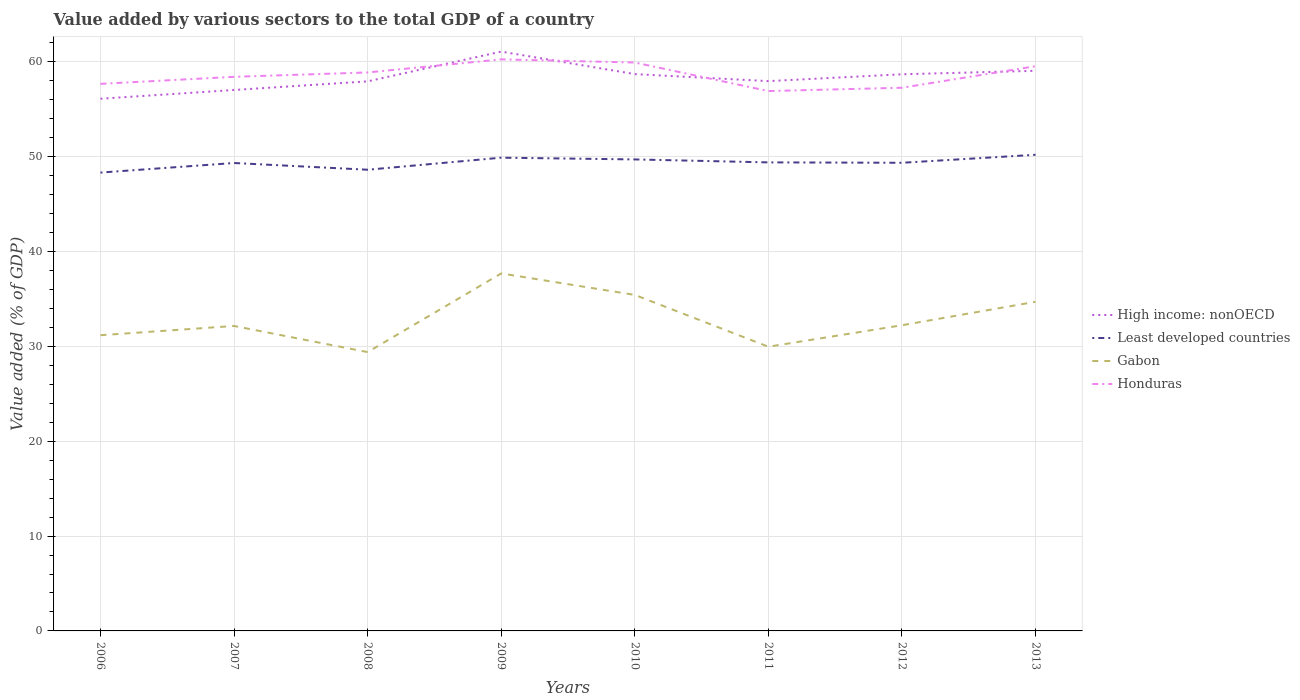Does the line corresponding to High income: nonOECD intersect with the line corresponding to Honduras?
Give a very brief answer. Yes. Across all years, what is the maximum value added by various sectors to the total GDP in High income: nonOECD?
Provide a short and direct response. 56.12. In which year was the value added by various sectors to the total GDP in Least developed countries maximum?
Ensure brevity in your answer.  2006. What is the total value added by various sectors to the total GDP in Honduras in the graph?
Your response must be concise. 0.76. What is the difference between the highest and the second highest value added by various sectors to the total GDP in Honduras?
Provide a short and direct response. 3.34. What is the difference between the highest and the lowest value added by various sectors to the total GDP in High income: nonOECD?
Your response must be concise. 4. Is the value added by various sectors to the total GDP in Least developed countries strictly greater than the value added by various sectors to the total GDP in High income: nonOECD over the years?
Offer a very short reply. Yes. How many years are there in the graph?
Ensure brevity in your answer.  8. What is the difference between two consecutive major ticks on the Y-axis?
Your answer should be very brief. 10. Does the graph contain any zero values?
Your answer should be very brief. No. Where does the legend appear in the graph?
Offer a terse response. Center right. How many legend labels are there?
Your response must be concise. 4. How are the legend labels stacked?
Give a very brief answer. Vertical. What is the title of the graph?
Provide a succinct answer. Value added by various sectors to the total GDP of a country. What is the label or title of the X-axis?
Your response must be concise. Years. What is the label or title of the Y-axis?
Provide a short and direct response. Value added (% of GDP). What is the Value added (% of GDP) of High income: nonOECD in 2006?
Provide a succinct answer. 56.12. What is the Value added (% of GDP) in Least developed countries in 2006?
Provide a short and direct response. 48.33. What is the Value added (% of GDP) in Gabon in 2006?
Offer a very short reply. 31.18. What is the Value added (% of GDP) in Honduras in 2006?
Ensure brevity in your answer.  57.69. What is the Value added (% of GDP) in High income: nonOECD in 2007?
Provide a short and direct response. 57.04. What is the Value added (% of GDP) in Least developed countries in 2007?
Give a very brief answer. 49.34. What is the Value added (% of GDP) in Gabon in 2007?
Offer a very short reply. 32.16. What is the Value added (% of GDP) in Honduras in 2007?
Ensure brevity in your answer.  58.43. What is the Value added (% of GDP) in High income: nonOECD in 2008?
Offer a very short reply. 57.95. What is the Value added (% of GDP) of Least developed countries in 2008?
Keep it short and to the point. 48.63. What is the Value added (% of GDP) of Gabon in 2008?
Your answer should be very brief. 29.4. What is the Value added (% of GDP) of Honduras in 2008?
Keep it short and to the point. 58.89. What is the Value added (% of GDP) of High income: nonOECD in 2009?
Offer a terse response. 61.09. What is the Value added (% of GDP) of Least developed countries in 2009?
Your response must be concise. 49.9. What is the Value added (% of GDP) in Gabon in 2009?
Give a very brief answer. 37.7. What is the Value added (% of GDP) of Honduras in 2009?
Your response must be concise. 60.27. What is the Value added (% of GDP) of High income: nonOECD in 2010?
Your answer should be very brief. 58.71. What is the Value added (% of GDP) of Least developed countries in 2010?
Offer a very short reply. 49.72. What is the Value added (% of GDP) in Gabon in 2010?
Your answer should be compact. 35.43. What is the Value added (% of GDP) of Honduras in 2010?
Keep it short and to the point. 59.93. What is the Value added (% of GDP) in High income: nonOECD in 2011?
Your answer should be very brief. 57.98. What is the Value added (% of GDP) of Least developed countries in 2011?
Your response must be concise. 49.41. What is the Value added (% of GDP) of Gabon in 2011?
Your answer should be very brief. 29.97. What is the Value added (% of GDP) in Honduras in 2011?
Provide a short and direct response. 56.93. What is the Value added (% of GDP) of High income: nonOECD in 2012?
Offer a very short reply. 58.7. What is the Value added (% of GDP) of Least developed countries in 2012?
Your answer should be very brief. 49.36. What is the Value added (% of GDP) in Gabon in 2012?
Your answer should be very brief. 32.23. What is the Value added (% of GDP) in Honduras in 2012?
Your answer should be very brief. 57.28. What is the Value added (% of GDP) in High income: nonOECD in 2013?
Provide a short and direct response. 59.06. What is the Value added (% of GDP) of Least developed countries in 2013?
Provide a short and direct response. 50.21. What is the Value added (% of GDP) in Gabon in 2013?
Ensure brevity in your answer.  34.71. What is the Value added (% of GDP) in Honduras in 2013?
Your response must be concise. 59.55. Across all years, what is the maximum Value added (% of GDP) of High income: nonOECD?
Your response must be concise. 61.09. Across all years, what is the maximum Value added (% of GDP) of Least developed countries?
Your answer should be very brief. 50.21. Across all years, what is the maximum Value added (% of GDP) in Gabon?
Offer a very short reply. 37.7. Across all years, what is the maximum Value added (% of GDP) in Honduras?
Offer a very short reply. 60.27. Across all years, what is the minimum Value added (% of GDP) in High income: nonOECD?
Offer a terse response. 56.12. Across all years, what is the minimum Value added (% of GDP) of Least developed countries?
Provide a short and direct response. 48.33. Across all years, what is the minimum Value added (% of GDP) in Gabon?
Provide a succinct answer. 29.4. Across all years, what is the minimum Value added (% of GDP) of Honduras?
Offer a very short reply. 56.93. What is the total Value added (% of GDP) in High income: nonOECD in the graph?
Your response must be concise. 466.65. What is the total Value added (% of GDP) in Least developed countries in the graph?
Offer a terse response. 394.9. What is the total Value added (% of GDP) in Gabon in the graph?
Provide a short and direct response. 262.78. What is the total Value added (% of GDP) of Honduras in the graph?
Ensure brevity in your answer.  468.96. What is the difference between the Value added (% of GDP) of High income: nonOECD in 2006 and that in 2007?
Make the answer very short. -0.92. What is the difference between the Value added (% of GDP) of Least developed countries in 2006 and that in 2007?
Your answer should be very brief. -1.01. What is the difference between the Value added (% of GDP) of Gabon in 2006 and that in 2007?
Provide a succinct answer. -0.98. What is the difference between the Value added (% of GDP) in Honduras in 2006 and that in 2007?
Your answer should be very brief. -0.74. What is the difference between the Value added (% of GDP) in High income: nonOECD in 2006 and that in 2008?
Offer a very short reply. -1.83. What is the difference between the Value added (% of GDP) in Least developed countries in 2006 and that in 2008?
Give a very brief answer. -0.3. What is the difference between the Value added (% of GDP) in Gabon in 2006 and that in 2008?
Your answer should be compact. 1.78. What is the difference between the Value added (% of GDP) in Honduras in 2006 and that in 2008?
Offer a very short reply. -1.2. What is the difference between the Value added (% of GDP) of High income: nonOECD in 2006 and that in 2009?
Your answer should be very brief. -4.97. What is the difference between the Value added (% of GDP) of Least developed countries in 2006 and that in 2009?
Your answer should be very brief. -1.57. What is the difference between the Value added (% of GDP) of Gabon in 2006 and that in 2009?
Your response must be concise. -6.51. What is the difference between the Value added (% of GDP) of Honduras in 2006 and that in 2009?
Offer a terse response. -2.58. What is the difference between the Value added (% of GDP) of High income: nonOECD in 2006 and that in 2010?
Your answer should be very brief. -2.6. What is the difference between the Value added (% of GDP) in Least developed countries in 2006 and that in 2010?
Offer a terse response. -1.39. What is the difference between the Value added (% of GDP) in Gabon in 2006 and that in 2010?
Keep it short and to the point. -4.25. What is the difference between the Value added (% of GDP) in Honduras in 2006 and that in 2010?
Provide a short and direct response. -2.25. What is the difference between the Value added (% of GDP) of High income: nonOECD in 2006 and that in 2011?
Make the answer very short. -1.86. What is the difference between the Value added (% of GDP) of Least developed countries in 2006 and that in 2011?
Ensure brevity in your answer.  -1.07. What is the difference between the Value added (% of GDP) in Gabon in 2006 and that in 2011?
Provide a short and direct response. 1.21. What is the difference between the Value added (% of GDP) of Honduras in 2006 and that in 2011?
Offer a terse response. 0.76. What is the difference between the Value added (% of GDP) of High income: nonOECD in 2006 and that in 2012?
Your answer should be very brief. -2.58. What is the difference between the Value added (% of GDP) of Least developed countries in 2006 and that in 2012?
Ensure brevity in your answer.  -1.03. What is the difference between the Value added (% of GDP) of Gabon in 2006 and that in 2012?
Provide a succinct answer. -1.05. What is the difference between the Value added (% of GDP) of Honduras in 2006 and that in 2012?
Make the answer very short. 0.41. What is the difference between the Value added (% of GDP) in High income: nonOECD in 2006 and that in 2013?
Give a very brief answer. -2.95. What is the difference between the Value added (% of GDP) of Least developed countries in 2006 and that in 2013?
Keep it short and to the point. -1.88. What is the difference between the Value added (% of GDP) of Gabon in 2006 and that in 2013?
Keep it short and to the point. -3.53. What is the difference between the Value added (% of GDP) in Honduras in 2006 and that in 2013?
Ensure brevity in your answer.  -1.86. What is the difference between the Value added (% of GDP) in High income: nonOECD in 2007 and that in 2008?
Make the answer very short. -0.91. What is the difference between the Value added (% of GDP) of Least developed countries in 2007 and that in 2008?
Provide a short and direct response. 0.71. What is the difference between the Value added (% of GDP) of Gabon in 2007 and that in 2008?
Your response must be concise. 2.76. What is the difference between the Value added (% of GDP) in Honduras in 2007 and that in 2008?
Provide a short and direct response. -0.46. What is the difference between the Value added (% of GDP) in High income: nonOECD in 2007 and that in 2009?
Provide a short and direct response. -4.05. What is the difference between the Value added (% of GDP) of Least developed countries in 2007 and that in 2009?
Give a very brief answer. -0.56. What is the difference between the Value added (% of GDP) in Gabon in 2007 and that in 2009?
Make the answer very short. -5.54. What is the difference between the Value added (% of GDP) in Honduras in 2007 and that in 2009?
Your response must be concise. -1.84. What is the difference between the Value added (% of GDP) of High income: nonOECD in 2007 and that in 2010?
Provide a short and direct response. -1.67. What is the difference between the Value added (% of GDP) in Least developed countries in 2007 and that in 2010?
Offer a very short reply. -0.38. What is the difference between the Value added (% of GDP) in Gabon in 2007 and that in 2010?
Ensure brevity in your answer.  -3.27. What is the difference between the Value added (% of GDP) in Honduras in 2007 and that in 2010?
Offer a terse response. -1.51. What is the difference between the Value added (% of GDP) of High income: nonOECD in 2007 and that in 2011?
Your answer should be very brief. -0.94. What is the difference between the Value added (% of GDP) of Least developed countries in 2007 and that in 2011?
Give a very brief answer. -0.07. What is the difference between the Value added (% of GDP) in Gabon in 2007 and that in 2011?
Your answer should be very brief. 2.19. What is the difference between the Value added (% of GDP) in Honduras in 2007 and that in 2011?
Keep it short and to the point. 1.5. What is the difference between the Value added (% of GDP) in High income: nonOECD in 2007 and that in 2012?
Ensure brevity in your answer.  -1.66. What is the difference between the Value added (% of GDP) of Least developed countries in 2007 and that in 2012?
Ensure brevity in your answer.  -0.02. What is the difference between the Value added (% of GDP) of Gabon in 2007 and that in 2012?
Provide a short and direct response. -0.08. What is the difference between the Value added (% of GDP) of Honduras in 2007 and that in 2012?
Provide a succinct answer. 1.15. What is the difference between the Value added (% of GDP) in High income: nonOECD in 2007 and that in 2013?
Provide a succinct answer. -2.02. What is the difference between the Value added (% of GDP) in Least developed countries in 2007 and that in 2013?
Provide a succinct answer. -0.87. What is the difference between the Value added (% of GDP) of Gabon in 2007 and that in 2013?
Give a very brief answer. -2.55. What is the difference between the Value added (% of GDP) of Honduras in 2007 and that in 2013?
Offer a terse response. -1.12. What is the difference between the Value added (% of GDP) of High income: nonOECD in 2008 and that in 2009?
Your answer should be very brief. -3.14. What is the difference between the Value added (% of GDP) of Least developed countries in 2008 and that in 2009?
Your answer should be compact. -1.27. What is the difference between the Value added (% of GDP) of Gabon in 2008 and that in 2009?
Ensure brevity in your answer.  -8.29. What is the difference between the Value added (% of GDP) of Honduras in 2008 and that in 2009?
Your answer should be very brief. -1.38. What is the difference between the Value added (% of GDP) in High income: nonOECD in 2008 and that in 2010?
Keep it short and to the point. -0.76. What is the difference between the Value added (% of GDP) in Least developed countries in 2008 and that in 2010?
Offer a very short reply. -1.09. What is the difference between the Value added (% of GDP) of Gabon in 2008 and that in 2010?
Keep it short and to the point. -6.03. What is the difference between the Value added (% of GDP) in Honduras in 2008 and that in 2010?
Your answer should be compact. -1.05. What is the difference between the Value added (% of GDP) in High income: nonOECD in 2008 and that in 2011?
Make the answer very short. -0.02. What is the difference between the Value added (% of GDP) in Least developed countries in 2008 and that in 2011?
Make the answer very short. -0.77. What is the difference between the Value added (% of GDP) of Gabon in 2008 and that in 2011?
Provide a succinct answer. -0.57. What is the difference between the Value added (% of GDP) of Honduras in 2008 and that in 2011?
Make the answer very short. 1.96. What is the difference between the Value added (% of GDP) of High income: nonOECD in 2008 and that in 2012?
Offer a very short reply. -0.75. What is the difference between the Value added (% of GDP) in Least developed countries in 2008 and that in 2012?
Your answer should be very brief. -0.73. What is the difference between the Value added (% of GDP) of Gabon in 2008 and that in 2012?
Give a very brief answer. -2.83. What is the difference between the Value added (% of GDP) in Honduras in 2008 and that in 2012?
Your response must be concise. 1.61. What is the difference between the Value added (% of GDP) of High income: nonOECD in 2008 and that in 2013?
Your answer should be very brief. -1.11. What is the difference between the Value added (% of GDP) in Least developed countries in 2008 and that in 2013?
Offer a terse response. -1.58. What is the difference between the Value added (% of GDP) in Gabon in 2008 and that in 2013?
Keep it short and to the point. -5.31. What is the difference between the Value added (% of GDP) of Honduras in 2008 and that in 2013?
Offer a terse response. -0.66. What is the difference between the Value added (% of GDP) in High income: nonOECD in 2009 and that in 2010?
Ensure brevity in your answer.  2.37. What is the difference between the Value added (% of GDP) in Least developed countries in 2009 and that in 2010?
Provide a succinct answer. 0.18. What is the difference between the Value added (% of GDP) in Gabon in 2009 and that in 2010?
Make the answer very short. 2.27. What is the difference between the Value added (% of GDP) in Honduras in 2009 and that in 2010?
Give a very brief answer. 0.34. What is the difference between the Value added (% of GDP) in High income: nonOECD in 2009 and that in 2011?
Keep it short and to the point. 3.11. What is the difference between the Value added (% of GDP) in Least developed countries in 2009 and that in 2011?
Ensure brevity in your answer.  0.5. What is the difference between the Value added (% of GDP) in Gabon in 2009 and that in 2011?
Ensure brevity in your answer.  7.73. What is the difference between the Value added (% of GDP) in Honduras in 2009 and that in 2011?
Your answer should be very brief. 3.34. What is the difference between the Value added (% of GDP) of High income: nonOECD in 2009 and that in 2012?
Ensure brevity in your answer.  2.39. What is the difference between the Value added (% of GDP) in Least developed countries in 2009 and that in 2012?
Provide a succinct answer. 0.54. What is the difference between the Value added (% of GDP) of Gabon in 2009 and that in 2012?
Offer a terse response. 5.46. What is the difference between the Value added (% of GDP) in Honduras in 2009 and that in 2012?
Ensure brevity in your answer.  2.99. What is the difference between the Value added (% of GDP) in High income: nonOECD in 2009 and that in 2013?
Ensure brevity in your answer.  2.02. What is the difference between the Value added (% of GDP) in Least developed countries in 2009 and that in 2013?
Make the answer very short. -0.3. What is the difference between the Value added (% of GDP) of Gabon in 2009 and that in 2013?
Keep it short and to the point. 2.99. What is the difference between the Value added (% of GDP) of Honduras in 2009 and that in 2013?
Offer a very short reply. 0.72. What is the difference between the Value added (% of GDP) in High income: nonOECD in 2010 and that in 2011?
Ensure brevity in your answer.  0.74. What is the difference between the Value added (% of GDP) in Least developed countries in 2010 and that in 2011?
Provide a short and direct response. 0.31. What is the difference between the Value added (% of GDP) in Gabon in 2010 and that in 2011?
Offer a terse response. 5.46. What is the difference between the Value added (% of GDP) of Honduras in 2010 and that in 2011?
Your answer should be compact. 3.01. What is the difference between the Value added (% of GDP) in High income: nonOECD in 2010 and that in 2012?
Offer a terse response. 0.02. What is the difference between the Value added (% of GDP) of Least developed countries in 2010 and that in 2012?
Make the answer very short. 0.35. What is the difference between the Value added (% of GDP) in Gabon in 2010 and that in 2012?
Your response must be concise. 3.2. What is the difference between the Value added (% of GDP) in Honduras in 2010 and that in 2012?
Make the answer very short. 2.66. What is the difference between the Value added (% of GDP) in High income: nonOECD in 2010 and that in 2013?
Provide a short and direct response. -0.35. What is the difference between the Value added (% of GDP) in Least developed countries in 2010 and that in 2013?
Offer a terse response. -0.49. What is the difference between the Value added (% of GDP) in Gabon in 2010 and that in 2013?
Your answer should be compact. 0.72. What is the difference between the Value added (% of GDP) in Honduras in 2010 and that in 2013?
Keep it short and to the point. 0.39. What is the difference between the Value added (% of GDP) in High income: nonOECD in 2011 and that in 2012?
Provide a short and direct response. -0.72. What is the difference between the Value added (% of GDP) of Least developed countries in 2011 and that in 2012?
Give a very brief answer. 0.04. What is the difference between the Value added (% of GDP) in Gabon in 2011 and that in 2012?
Your answer should be compact. -2.26. What is the difference between the Value added (% of GDP) in Honduras in 2011 and that in 2012?
Offer a very short reply. -0.35. What is the difference between the Value added (% of GDP) in High income: nonOECD in 2011 and that in 2013?
Ensure brevity in your answer.  -1.09. What is the difference between the Value added (% of GDP) of Least developed countries in 2011 and that in 2013?
Your answer should be compact. -0.8. What is the difference between the Value added (% of GDP) of Gabon in 2011 and that in 2013?
Offer a very short reply. -4.74. What is the difference between the Value added (% of GDP) in Honduras in 2011 and that in 2013?
Your response must be concise. -2.62. What is the difference between the Value added (% of GDP) in High income: nonOECD in 2012 and that in 2013?
Offer a terse response. -0.37. What is the difference between the Value added (% of GDP) of Least developed countries in 2012 and that in 2013?
Provide a short and direct response. -0.84. What is the difference between the Value added (% of GDP) of Gabon in 2012 and that in 2013?
Offer a terse response. -2.48. What is the difference between the Value added (% of GDP) in Honduras in 2012 and that in 2013?
Provide a succinct answer. -2.27. What is the difference between the Value added (% of GDP) in High income: nonOECD in 2006 and the Value added (% of GDP) in Least developed countries in 2007?
Your answer should be very brief. 6.78. What is the difference between the Value added (% of GDP) in High income: nonOECD in 2006 and the Value added (% of GDP) in Gabon in 2007?
Offer a terse response. 23.96. What is the difference between the Value added (% of GDP) in High income: nonOECD in 2006 and the Value added (% of GDP) in Honduras in 2007?
Provide a succinct answer. -2.31. What is the difference between the Value added (% of GDP) in Least developed countries in 2006 and the Value added (% of GDP) in Gabon in 2007?
Give a very brief answer. 16.18. What is the difference between the Value added (% of GDP) of Least developed countries in 2006 and the Value added (% of GDP) of Honduras in 2007?
Make the answer very short. -10.1. What is the difference between the Value added (% of GDP) in Gabon in 2006 and the Value added (% of GDP) in Honduras in 2007?
Provide a succinct answer. -27.25. What is the difference between the Value added (% of GDP) of High income: nonOECD in 2006 and the Value added (% of GDP) of Least developed countries in 2008?
Your answer should be compact. 7.49. What is the difference between the Value added (% of GDP) in High income: nonOECD in 2006 and the Value added (% of GDP) in Gabon in 2008?
Give a very brief answer. 26.72. What is the difference between the Value added (% of GDP) in High income: nonOECD in 2006 and the Value added (% of GDP) in Honduras in 2008?
Your answer should be very brief. -2.77. What is the difference between the Value added (% of GDP) of Least developed countries in 2006 and the Value added (% of GDP) of Gabon in 2008?
Offer a very short reply. 18.93. What is the difference between the Value added (% of GDP) in Least developed countries in 2006 and the Value added (% of GDP) in Honduras in 2008?
Ensure brevity in your answer.  -10.56. What is the difference between the Value added (% of GDP) of Gabon in 2006 and the Value added (% of GDP) of Honduras in 2008?
Give a very brief answer. -27.71. What is the difference between the Value added (% of GDP) of High income: nonOECD in 2006 and the Value added (% of GDP) of Least developed countries in 2009?
Make the answer very short. 6.21. What is the difference between the Value added (% of GDP) of High income: nonOECD in 2006 and the Value added (% of GDP) of Gabon in 2009?
Keep it short and to the point. 18.42. What is the difference between the Value added (% of GDP) in High income: nonOECD in 2006 and the Value added (% of GDP) in Honduras in 2009?
Ensure brevity in your answer.  -4.15. What is the difference between the Value added (% of GDP) of Least developed countries in 2006 and the Value added (% of GDP) of Gabon in 2009?
Offer a very short reply. 10.64. What is the difference between the Value added (% of GDP) in Least developed countries in 2006 and the Value added (% of GDP) in Honduras in 2009?
Keep it short and to the point. -11.94. What is the difference between the Value added (% of GDP) of Gabon in 2006 and the Value added (% of GDP) of Honduras in 2009?
Offer a very short reply. -29.09. What is the difference between the Value added (% of GDP) of High income: nonOECD in 2006 and the Value added (% of GDP) of Least developed countries in 2010?
Offer a terse response. 6.4. What is the difference between the Value added (% of GDP) in High income: nonOECD in 2006 and the Value added (% of GDP) in Gabon in 2010?
Make the answer very short. 20.69. What is the difference between the Value added (% of GDP) of High income: nonOECD in 2006 and the Value added (% of GDP) of Honduras in 2010?
Provide a succinct answer. -3.82. What is the difference between the Value added (% of GDP) of Least developed countries in 2006 and the Value added (% of GDP) of Gabon in 2010?
Make the answer very short. 12.9. What is the difference between the Value added (% of GDP) in Least developed countries in 2006 and the Value added (% of GDP) in Honduras in 2010?
Make the answer very short. -11.6. What is the difference between the Value added (% of GDP) of Gabon in 2006 and the Value added (% of GDP) of Honduras in 2010?
Make the answer very short. -28.75. What is the difference between the Value added (% of GDP) of High income: nonOECD in 2006 and the Value added (% of GDP) of Least developed countries in 2011?
Offer a terse response. 6.71. What is the difference between the Value added (% of GDP) of High income: nonOECD in 2006 and the Value added (% of GDP) of Gabon in 2011?
Provide a short and direct response. 26.15. What is the difference between the Value added (% of GDP) in High income: nonOECD in 2006 and the Value added (% of GDP) in Honduras in 2011?
Your response must be concise. -0.81. What is the difference between the Value added (% of GDP) of Least developed countries in 2006 and the Value added (% of GDP) of Gabon in 2011?
Your response must be concise. 18.36. What is the difference between the Value added (% of GDP) of Least developed countries in 2006 and the Value added (% of GDP) of Honduras in 2011?
Provide a succinct answer. -8.59. What is the difference between the Value added (% of GDP) of Gabon in 2006 and the Value added (% of GDP) of Honduras in 2011?
Make the answer very short. -25.74. What is the difference between the Value added (% of GDP) in High income: nonOECD in 2006 and the Value added (% of GDP) in Least developed countries in 2012?
Provide a succinct answer. 6.75. What is the difference between the Value added (% of GDP) in High income: nonOECD in 2006 and the Value added (% of GDP) in Gabon in 2012?
Give a very brief answer. 23.89. What is the difference between the Value added (% of GDP) of High income: nonOECD in 2006 and the Value added (% of GDP) of Honduras in 2012?
Make the answer very short. -1.16. What is the difference between the Value added (% of GDP) of Least developed countries in 2006 and the Value added (% of GDP) of Gabon in 2012?
Make the answer very short. 16.1. What is the difference between the Value added (% of GDP) of Least developed countries in 2006 and the Value added (% of GDP) of Honduras in 2012?
Your response must be concise. -8.94. What is the difference between the Value added (% of GDP) of Gabon in 2006 and the Value added (% of GDP) of Honduras in 2012?
Offer a terse response. -26.09. What is the difference between the Value added (% of GDP) in High income: nonOECD in 2006 and the Value added (% of GDP) in Least developed countries in 2013?
Give a very brief answer. 5.91. What is the difference between the Value added (% of GDP) in High income: nonOECD in 2006 and the Value added (% of GDP) in Gabon in 2013?
Make the answer very short. 21.41. What is the difference between the Value added (% of GDP) of High income: nonOECD in 2006 and the Value added (% of GDP) of Honduras in 2013?
Offer a terse response. -3.43. What is the difference between the Value added (% of GDP) of Least developed countries in 2006 and the Value added (% of GDP) of Gabon in 2013?
Ensure brevity in your answer.  13.62. What is the difference between the Value added (% of GDP) in Least developed countries in 2006 and the Value added (% of GDP) in Honduras in 2013?
Your answer should be compact. -11.21. What is the difference between the Value added (% of GDP) in Gabon in 2006 and the Value added (% of GDP) in Honduras in 2013?
Offer a terse response. -28.36. What is the difference between the Value added (% of GDP) in High income: nonOECD in 2007 and the Value added (% of GDP) in Least developed countries in 2008?
Your answer should be compact. 8.41. What is the difference between the Value added (% of GDP) of High income: nonOECD in 2007 and the Value added (% of GDP) of Gabon in 2008?
Provide a succinct answer. 27.64. What is the difference between the Value added (% of GDP) of High income: nonOECD in 2007 and the Value added (% of GDP) of Honduras in 2008?
Your response must be concise. -1.85. What is the difference between the Value added (% of GDP) in Least developed countries in 2007 and the Value added (% of GDP) in Gabon in 2008?
Make the answer very short. 19.94. What is the difference between the Value added (% of GDP) in Least developed countries in 2007 and the Value added (% of GDP) in Honduras in 2008?
Your answer should be compact. -9.55. What is the difference between the Value added (% of GDP) of Gabon in 2007 and the Value added (% of GDP) of Honduras in 2008?
Provide a succinct answer. -26.73. What is the difference between the Value added (% of GDP) in High income: nonOECD in 2007 and the Value added (% of GDP) in Least developed countries in 2009?
Offer a very short reply. 7.14. What is the difference between the Value added (% of GDP) of High income: nonOECD in 2007 and the Value added (% of GDP) of Gabon in 2009?
Your answer should be very brief. 19.34. What is the difference between the Value added (% of GDP) in High income: nonOECD in 2007 and the Value added (% of GDP) in Honduras in 2009?
Provide a succinct answer. -3.23. What is the difference between the Value added (% of GDP) of Least developed countries in 2007 and the Value added (% of GDP) of Gabon in 2009?
Provide a succinct answer. 11.64. What is the difference between the Value added (% of GDP) of Least developed countries in 2007 and the Value added (% of GDP) of Honduras in 2009?
Give a very brief answer. -10.93. What is the difference between the Value added (% of GDP) in Gabon in 2007 and the Value added (% of GDP) in Honduras in 2009?
Your answer should be compact. -28.11. What is the difference between the Value added (% of GDP) in High income: nonOECD in 2007 and the Value added (% of GDP) in Least developed countries in 2010?
Offer a very short reply. 7.32. What is the difference between the Value added (% of GDP) of High income: nonOECD in 2007 and the Value added (% of GDP) of Gabon in 2010?
Your answer should be very brief. 21.61. What is the difference between the Value added (% of GDP) in High income: nonOECD in 2007 and the Value added (% of GDP) in Honduras in 2010?
Ensure brevity in your answer.  -2.9. What is the difference between the Value added (% of GDP) of Least developed countries in 2007 and the Value added (% of GDP) of Gabon in 2010?
Provide a short and direct response. 13.91. What is the difference between the Value added (% of GDP) in Least developed countries in 2007 and the Value added (% of GDP) in Honduras in 2010?
Your answer should be compact. -10.59. What is the difference between the Value added (% of GDP) of Gabon in 2007 and the Value added (% of GDP) of Honduras in 2010?
Ensure brevity in your answer.  -27.78. What is the difference between the Value added (% of GDP) of High income: nonOECD in 2007 and the Value added (% of GDP) of Least developed countries in 2011?
Keep it short and to the point. 7.63. What is the difference between the Value added (% of GDP) in High income: nonOECD in 2007 and the Value added (% of GDP) in Gabon in 2011?
Offer a terse response. 27.07. What is the difference between the Value added (% of GDP) of High income: nonOECD in 2007 and the Value added (% of GDP) of Honduras in 2011?
Give a very brief answer. 0.11. What is the difference between the Value added (% of GDP) of Least developed countries in 2007 and the Value added (% of GDP) of Gabon in 2011?
Your response must be concise. 19.37. What is the difference between the Value added (% of GDP) of Least developed countries in 2007 and the Value added (% of GDP) of Honduras in 2011?
Keep it short and to the point. -7.59. What is the difference between the Value added (% of GDP) in Gabon in 2007 and the Value added (% of GDP) in Honduras in 2011?
Provide a short and direct response. -24.77. What is the difference between the Value added (% of GDP) in High income: nonOECD in 2007 and the Value added (% of GDP) in Least developed countries in 2012?
Give a very brief answer. 7.68. What is the difference between the Value added (% of GDP) of High income: nonOECD in 2007 and the Value added (% of GDP) of Gabon in 2012?
Your answer should be very brief. 24.81. What is the difference between the Value added (% of GDP) in High income: nonOECD in 2007 and the Value added (% of GDP) in Honduras in 2012?
Offer a terse response. -0.24. What is the difference between the Value added (% of GDP) in Least developed countries in 2007 and the Value added (% of GDP) in Gabon in 2012?
Your response must be concise. 17.11. What is the difference between the Value added (% of GDP) in Least developed countries in 2007 and the Value added (% of GDP) in Honduras in 2012?
Your answer should be compact. -7.94. What is the difference between the Value added (% of GDP) in Gabon in 2007 and the Value added (% of GDP) in Honduras in 2012?
Your answer should be very brief. -25.12. What is the difference between the Value added (% of GDP) in High income: nonOECD in 2007 and the Value added (% of GDP) in Least developed countries in 2013?
Your answer should be compact. 6.83. What is the difference between the Value added (% of GDP) of High income: nonOECD in 2007 and the Value added (% of GDP) of Gabon in 2013?
Offer a very short reply. 22.33. What is the difference between the Value added (% of GDP) of High income: nonOECD in 2007 and the Value added (% of GDP) of Honduras in 2013?
Offer a very short reply. -2.51. What is the difference between the Value added (% of GDP) in Least developed countries in 2007 and the Value added (% of GDP) in Gabon in 2013?
Your answer should be very brief. 14.63. What is the difference between the Value added (% of GDP) in Least developed countries in 2007 and the Value added (% of GDP) in Honduras in 2013?
Ensure brevity in your answer.  -10.21. What is the difference between the Value added (% of GDP) of Gabon in 2007 and the Value added (% of GDP) of Honduras in 2013?
Give a very brief answer. -27.39. What is the difference between the Value added (% of GDP) in High income: nonOECD in 2008 and the Value added (% of GDP) in Least developed countries in 2009?
Keep it short and to the point. 8.05. What is the difference between the Value added (% of GDP) in High income: nonOECD in 2008 and the Value added (% of GDP) in Gabon in 2009?
Your response must be concise. 20.25. What is the difference between the Value added (% of GDP) of High income: nonOECD in 2008 and the Value added (% of GDP) of Honduras in 2009?
Your answer should be very brief. -2.32. What is the difference between the Value added (% of GDP) of Least developed countries in 2008 and the Value added (% of GDP) of Gabon in 2009?
Offer a very short reply. 10.94. What is the difference between the Value added (% of GDP) in Least developed countries in 2008 and the Value added (% of GDP) in Honduras in 2009?
Provide a succinct answer. -11.64. What is the difference between the Value added (% of GDP) in Gabon in 2008 and the Value added (% of GDP) in Honduras in 2009?
Give a very brief answer. -30.87. What is the difference between the Value added (% of GDP) of High income: nonOECD in 2008 and the Value added (% of GDP) of Least developed countries in 2010?
Make the answer very short. 8.23. What is the difference between the Value added (% of GDP) of High income: nonOECD in 2008 and the Value added (% of GDP) of Gabon in 2010?
Offer a terse response. 22.52. What is the difference between the Value added (% of GDP) in High income: nonOECD in 2008 and the Value added (% of GDP) in Honduras in 2010?
Offer a very short reply. -1.98. What is the difference between the Value added (% of GDP) in Least developed countries in 2008 and the Value added (% of GDP) in Gabon in 2010?
Offer a very short reply. 13.2. What is the difference between the Value added (% of GDP) of Least developed countries in 2008 and the Value added (% of GDP) of Honduras in 2010?
Your answer should be very brief. -11.3. What is the difference between the Value added (% of GDP) of Gabon in 2008 and the Value added (% of GDP) of Honduras in 2010?
Provide a short and direct response. -30.53. What is the difference between the Value added (% of GDP) of High income: nonOECD in 2008 and the Value added (% of GDP) of Least developed countries in 2011?
Your answer should be compact. 8.54. What is the difference between the Value added (% of GDP) in High income: nonOECD in 2008 and the Value added (% of GDP) in Gabon in 2011?
Your response must be concise. 27.98. What is the difference between the Value added (% of GDP) of High income: nonOECD in 2008 and the Value added (% of GDP) of Honduras in 2011?
Your answer should be compact. 1.02. What is the difference between the Value added (% of GDP) of Least developed countries in 2008 and the Value added (% of GDP) of Gabon in 2011?
Your answer should be compact. 18.66. What is the difference between the Value added (% of GDP) of Least developed countries in 2008 and the Value added (% of GDP) of Honduras in 2011?
Offer a terse response. -8.3. What is the difference between the Value added (% of GDP) in Gabon in 2008 and the Value added (% of GDP) in Honduras in 2011?
Offer a very short reply. -27.53. What is the difference between the Value added (% of GDP) in High income: nonOECD in 2008 and the Value added (% of GDP) in Least developed countries in 2012?
Your response must be concise. 8.59. What is the difference between the Value added (% of GDP) in High income: nonOECD in 2008 and the Value added (% of GDP) in Gabon in 2012?
Offer a very short reply. 25.72. What is the difference between the Value added (% of GDP) in High income: nonOECD in 2008 and the Value added (% of GDP) in Honduras in 2012?
Your answer should be compact. 0.67. What is the difference between the Value added (% of GDP) in Least developed countries in 2008 and the Value added (% of GDP) in Gabon in 2012?
Provide a succinct answer. 16.4. What is the difference between the Value added (% of GDP) of Least developed countries in 2008 and the Value added (% of GDP) of Honduras in 2012?
Your response must be concise. -8.65. What is the difference between the Value added (% of GDP) of Gabon in 2008 and the Value added (% of GDP) of Honduras in 2012?
Your response must be concise. -27.88. What is the difference between the Value added (% of GDP) in High income: nonOECD in 2008 and the Value added (% of GDP) in Least developed countries in 2013?
Provide a short and direct response. 7.74. What is the difference between the Value added (% of GDP) of High income: nonOECD in 2008 and the Value added (% of GDP) of Gabon in 2013?
Ensure brevity in your answer.  23.24. What is the difference between the Value added (% of GDP) in High income: nonOECD in 2008 and the Value added (% of GDP) in Honduras in 2013?
Your answer should be very brief. -1.6. What is the difference between the Value added (% of GDP) of Least developed countries in 2008 and the Value added (% of GDP) of Gabon in 2013?
Provide a short and direct response. 13.92. What is the difference between the Value added (% of GDP) of Least developed countries in 2008 and the Value added (% of GDP) of Honduras in 2013?
Make the answer very short. -10.91. What is the difference between the Value added (% of GDP) of Gabon in 2008 and the Value added (% of GDP) of Honduras in 2013?
Provide a succinct answer. -30.14. What is the difference between the Value added (% of GDP) of High income: nonOECD in 2009 and the Value added (% of GDP) of Least developed countries in 2010?
Offer a terse response. 11.37. What is the difference between the Value added (% of GDP) of High income: nonOECD in 2009 and the Value added (% of GDP) of Gabon in 2010?
Keep it short and to the point. 25.66. What is the difference between the Value added (% of GDP) in High income: nonOECD in 2009 and the Value added (% of GDP) in Honduras in 2010?
Ensure brevity in your answer.  1.15. What is the difference between the Value added (% of GDP) of Least developed countries in 2009 and the Value added (% of GDP) of Gabon in 2010?
Provide a short and direct response. 14.47. What is the difference between the Value added (% of GDP) in Least developed countries in 2009 and the Value added (% of GDP) in Honduras in 2010?
Make the answer very short. -10.03. What is the difference between the Value added (% of GDP) of Gabon in 2009 and the Value added (% of GDP) of Honduras in 2010?
Offer a terse response. -22.24. What is the difference between the Value added (% of GDP) of High income: nonOECD in 2009 and the Value added (% of GDP) of Least developed countries in 2011?
Make the answer very short. 11.68. What is the difference between the Value added (% of GDP) in High income: nonOECD in 2009 and the Value added (% of GDP) in Gabon in 2011?
Your answer should be very brief. 31.12. What is the difference between the Value added (% of GDP) of High income: nonOECD in 2009 and the Value added (% of GDP) of Honduras in 2011?
Offer a very short reply. 4.16. What is the difference between the Value added (% of GDP) of Least developed countries in 2009 and the Value added (% of GDP) of Gabon in 2011?
Your answer should be very brief. 19.93. What is the difference between the Value added (% of GDP) in Least developed countries in 2009 and the Value added (% of GDP) in Honduras in 2011?
Offer a terse response. -7.02. What is the difference between the Value added (% of GDP) of Gabon in 2009 and the Value added (% of GDP) of Honduras in 2011?
Your answer should be very brief. -19.23. What is the difference between the Value added (% of GDP) in High income: nonOECD in 2009 and the Value added (% of GDP) in Least developed countries in 2012?
Provide a short and direct response. 11.72. What is the difference between the Value added (% of GDP) in High income: nonOECD in 2009 and the Value added (% of GDP) in Gabon in 2012?
Offer a terse response. 28.86. What is the difference between the Value added (% of GDP) of High income: nonOECD in 2009 and the Value added (% of GDP) of Honduras in 2012?
Offer a terse response. 3.81. What is the difference between the Value added (% of GDP) in Least developed countries in 2009 and the Value added (% of GDP) in Gabon in 2012?
Keep it short and to the point. 17.67. What is the difference between the Value added (% of GDP) of Least developed countries in 2009 and the Value added (% of GDP) of Honduras in 2012?
Make the answer very short. -7.37. What is the difference between the Value added (% of GDP) of Gabon in 2009 and the Value added (% of GDP) of Honduras in 2012?
Your response must be concise. -19.58. What is the difference between the Value added (% of GDP) of High income: nonOECD in 2009 and the Value added (% of GDP) of Least developed countries in 2013?
Keep it short and to the point. 10.88. What is the difference between the Value added (% of GDP) in High income: nonOECD in 2009 and the Value added (% of GDP) in Gabon in 2013?
Offer a very short reply. 26.38. What is the difference between the Value added (% of GDP) of High income: nonOECD in 2009 and the Value added (% of GDP) of Honduras in 2013?
Keep it short and to the point. 1.54. What is the difference between the Value added (% of GDP) in Least developed countries in 2009 and the Value added (% of GDP) in Gabon in 2013?
Give a very brief answer. 15.19. What is the difference between the Value added (% of GDP) of Least developed countries in 2009 and the Value added (% of GDP) of Honduras in 2013?
Your answer should be compact. -9.64. What is the difference between the Value added (% of GDP) in Gabon in 2009 and the Value added (% of GDP) in Honduras in 2013?
Provide a succinct answer. -21.85. What is the difference between the Value added (% of GDP) of High income: nonOECD in 2010 and the Value added (% of GDP) of Least developed countries in 2011?
Provide a short and direct response. 9.31. What is the difference between the Value added (% of GDP) of High income: nonOECD in 2010 and the Value added (% of GDP) of Gabon in 2011?
Provide a succinct answer. 28.74. What is the difference between the Value added (% of GDP) of High income: nonOECD in 2010 and the Value added (% of GDP) of Honduras in 2011?
Provide a short and direct response. 1.79. What is the difference between the Value added (% of GDP) of Least developed countries in 2010 and the Value added (% of GDP) of Gabon in 2011?
Make the answer very short. 19.75. What is the difference between the Value added (% of GDP) of Least developed countries in 2010 and the Value added (% of GDP) of Honduras in 2011?
Provide a succinct answer. -7.21. What is the difference between the Value added (% of GDP) of Gabon in 2010 and the Value added (% of GDP) of Honduras in 2011?
Your answer should be compact. -21.5. What is the difference between the Value added (% of GDP) in High income: nonOECD in 2010 and the Value added (% of GDP) in Least developed countries in 2012?
Provide a succinct answer. 9.35. What is the difference between the Value added (% of GDP) of High income: nonOECD in 2010 and the Value added (% of GDP) of Gabon in 2012?
Provide a succinct answer. 26.48. What is the difference between the Value added (% of GDP) of High income: nonOECD in 2010 and the Value added (% of GDP) of Honduras in 2012?
Give a very brief answer. 1.44. What is the difference between the Value added (% of GDP) in Least developed countries in 2010 and the Value added (% of GDP) in Gabon in 2012?
Offer a terse response. 17.49. What is the difference between the Value added (% of GDP) of Least developed countries in 2010 and the Value added (% of GDP) of Honduras in 2012?
Keep it short and to the point. -7.56. What is the difference between the Value added (% of GDP) in Gabon in 2010 and the Value added (% of GDP) in Honduras in 2012?
Offer a very short reply. -21.85. What is the difference between the Value added (% of GDP) of High income: nonOECD in 2010 and the Value added (% of GDP) of Least developed countries in 2013?
Your answer should be very brief. 8.51. What is the difference between the Value added (% of GDP) in High income: nonOECD in 2010 and the Value added (% of GDP) in Gabon in 2013?
Give a very brief answer. 24.01. What is the difference between the Value added (% of GDP) in High income: nonOECD in 2010 and the Value added (% of GDP) in Honduras in 2013?
Give a very brief answer. -0.83. What is the difference between the Value added (% of GDP) in Least developed countries in 2010 and the Value added (% of GDP) in Gabon in 2013?
Keep it short and to the point. 15.01. What is the difference between the Value added (% of GDP) in Least developed countries in 2010 and the Value added (% of GDP) in Honduras in 2013?
Ensure brevity in your answer.  -9.83. What is the difference between the Value added (% of GDP) in Gabon in 2010 and the Value added (% of GDP) in Honduras in 2013?
Ensure brevity in your answer.  -24.12. What is the difference between the Value added (% of GDP) of High income: nonOECD in 2011 and the Value added (% of GDP) of Least developed countries in 2012?
Make the answer very short. 8.61. What is the difference between the Value added (% of GDP) in High income: nonOECD in 2011 and the Value added (% of GDP) in Gabon in 2012?
Offer a terse response. 25.74. What is the difference between the Value added (% of GDP) in High income: nonOECD in 2011 and the Value added (% of GDP) in Honduras in 2012?
Provide a short and direct response. 0.7. What is the difference between the Value added (% of GDP) in Least developed countries in 2011 and the Value added (% of GDP) in Gabon in 2012?
Your response must be concise. 17.17. What is the difference between the Value added (% of GDP) of Least developed countries in 2011 and the Value added (% of GDP) of Honduras in 2012?
Provide a short and direct response. -7.87. What is the difference between the Value added (% of GDP) of Gabon in 2011 and the Value added (% of GDP) of Honduras in 2012?
Ensure brevity in your answer.  -27.31. What is the difference between the Value added (% of GDP) of High income: nonOECD in 2011 and the Value added (% of GDP) of Least developed countries in 2013?
Your answer should be very brief. 7.77. What is the difference between the Value added (% of GDP) in High income: nonOECD in 2011 and the Value added (% of GDP) in Gabon in 2013?
Provide a short and direct response. 23.27. What is the difference between the Value added (% of GDP) in High income: nonOECD in 2011 and the Value added (% of GDP) in Honduras in 2013?
Make the answer very short. -1.57. What is the difference between the Value added (% of GDP) in Least developed countries in 2011 and the Value added (% of GDP) in Gabon in 2013?
Make the answer very short. 14.7. What is the difference between the Value added (% of GDP) in Least developed countries in 2011 and the Value added (% of GDP) in Honduras in 2013?
Ensure brevity in your answer.  -10.14. What is the difference between the Value added (% of GDP) in Gabon in 2011 and the Value added (% of GDP) in Honduras in 2013?
Provide a short and direct response. -29.58. What is the difference between the Value added (% of GDP) in High income: nonOECD in 2012 and the Value added (% of GDP) in Least developed countries in 2013?
Your answer should be very brief. 8.49. What is the difference between the Value added (% of GDP) in High income: nonOECD in 2012 and the Value added (% of GDP) in Gabon in 2013?
Offer a terse response. 23.99. What is the difference between the Value added (% of GDP) of High income: nonOECD in 2012 and the Value added (% of GDP) of Honduras in 2013?
Provide a succinct answer. -0.85. What is the difference between the Value added (% of GDP) of Least developed countries in 2012 and the Value added (% of GDP) of Gabon in 2013?
Offer a very short reply. 14.66. What is the difference between the Value added (% of GDP) of Least developed countries in 2012 and the Value added (% of GDP) of Honduras in 2013?
Ensure brevity in your answer.  -10.18. What is the difference between the Value added (% of GDP) in Gabon in 2012 and the Value added (% of GDP) in Honduras in 2013?
Your answer should be very brief. -27.31. What is the average Value added (% of GDP) of High income: nonOECD per year?
Keep it short and to the point. 58.33. What is the average Value added (% of GDP) of Least developed countries per year?
Your response must be concise. 49.36. What is the average Value added (% of GDP) in Gabon per year?
Your answer should be compact. 32.85. What is the average Value added (% of GDP) in Honduras per year?
Your response must be concise. 58.62. In the year 2006, what is the difference between the Value added (% of GDP) in High income: nonOECD and Value added (% of GDP) in Least developed countries?
Make the answer very short. 7.79. In the year 2006, what is the difference between the Value added (% of GDP) in High income: nonOECD and Value added (% of GDP) in Gabon?
Offer a very short reply. 24.94. In the year 2006, what is the difference between the Value added (% of GDP) in High income: nonOECD and Value added (% of GDP) in Honduras?
Provide a short and direct response. -1.57. In the year 2006, what is the difference between the Value added (% of GDP) of Least developed countries and Value added (% of GDP) of Gabon?
Offer a terse response. 17.15. In the year 2006, what is the difference between the Value added (% of GDP) in Least developed countries and Value added (% of GDP) in Honduras?
Offer a terse response. -9.35. In the year 2006, what is the difference between the Value added (% of GDP) in Gabon and Value added (% of GDP) in Honduras?
Your answer should be very brief. -26.5. In the year 2007, what is the difference between the Value added (% of GDP) in High income: nonOECD and Value added (% of GDP) in Least developed countries?
Give a very brief answer. 7.7. In the year 2007, what is the difference between the Value added (% of GDP) of High income: nonOECD and Value added (% of GDP) of Gabon?
Keep it short and to the point. 24.88. In the year 2007, what is the difference between the Value added (% of GDP) in High income: nonOECD and Value added (% of GDP) in Honduras?
Give a very brief answer. -1.39. In the year 2007, what is the difference between the Value added (% of GDP) in Least developed countries and Value added (% of GDP) in Gabon?
Your answer should be compact. 17.18. In the year 2007, what is the difference between the Value added (% of GDP) of Least developed countries and Value added (% of GDP) of Honduras?
Your answer should be very brief. -9.09. In the year 2007, what is the difference between the Value added (% of GDP) of Gabon and Value added (% of GDP) of Honduras?
Your answer should be very brief. -26.27. In the year 2008, what is the difference between the Value added (% of GDP) of High income: nonOECD and Value added (% of GDP) of Least developed countries?
Your answer should be very brief. 9.32. In the year 2008, what is the difference between the Value added (% of GDP) of High income: nonOECD and Value added (% of GDP) of Gabon?
Ensure brevity in your answer.  28.55. In the year 2008, what is the difference between the Value added (% of GDP) in High income: nonOECD and Value added (% of GDP) in Honduras?
Provide a succinct answer. -0.94. In the year 2008, what is the difference between the Value added (% of GDP) in Least developed countries and Value added (% of GDP) in Gabon?
Make the answer very short. 19.23. In the year 2008, what is the difference between the Value added (% of GDP) of Least developed countries and Value added (% of GDP) of Honduras?
Ensure brevity in your answer.  -10.26. In the year 2008, what is the difference between the Value added (% of GDP) of Gabon and Value added (% of GDP) of Honduras?
Provide a short and direct response. -29.49. In the year 2009, what is the difference between the Value added (% of GDP) in High income: nonOECD and Value added (% of GDP) in Least developed countries?
Keep it short and to the point. 11.19. In the year 2009, what is the difference between the Value added (% of GDP) in High income: nonOECD and Value added (% of GDP) in Gabon?
Keep it short and to the point. 23.39. In the year 2009, what is the difference between the Value added (% of GDP) in High income: nonOECD and Value added (% of GDP) in Honduras?
Give a very brief answer. 0.82. In the year 2009, what is the difference between the Value added (% of GDP) of Least developed countries and Value added (% of GDP) of Gabon?
Offer a very short reply. 12.21. In the year 2009, what is the difference between the Value added (% of GDP) of Least developed countries and Value added (% of GDP) of Honduras?
Ensure brevity in your answer.  -10.37. In the year 2009, what is the difference between the Value added (% of GDP) of Gabon and Value added (% of GDP) of Honduras?
Keep it short and to the point. -22.57. In the year 2010, what is the difference between the Value added (% of GDP) of High income: nonOECD and Value added (% of GDP) of Least developed countries?
Ensure brevity in your answer.  9. In the year 2010, what is the difference between the Value added (% of GDP) of High income: nonOECD and Value added (% of GDP) of Gabon?
Make the answer very short. 23.28. In the year 2010, what is the difference between the Value added (% of GDP) of High income: nonOECD and Value added (% of GDP) of Honduras?
Provide a short and direct response. -1.22. In the year 2010, what is the difference between the Value added (% of GDP) in Least developed countries and Value added (% of GDP) in Gabon?
Your response must be concise. 14.29. In the year 2010, what is the difference between the Value added (% of GDP) of Least developed countries and Value added (% of GDP) of Honduras?
Keep it short and to the point. -10.22. In the year 2010, what is the difference between the Value added (% of GDP) of Gabon and Value added (% of GDP) of Honduras?
Give a very brief answer. -24.5. In the year 2011, what is the difference between the Value added (% of GDP) of High income: nonOECD and Value added (% of GDP) of Least developed countries?
Your answer should be very brief. 8.57. In the year 2011, what is the difference between the Value added (% of GDP) in High income: nonOECD and Value added (% of GDP) in Gabon?
Offer a terse response. 28.01. In the year 2011, what is the difference between the Value added (% of GDP) in High income: nonOECD and Value added (% of GDP) in Honduras?
Provide a short and direct response. 1.05. In the year 2011, what is the difference between the Value added (% of GDP) of Least developed countries and Value added (% of GDP) of Gabon?
Offer a terse response. 19.44. In the year 2011, what is the difference between the Value added (% of GDP) in Least developed countries and Value added (% of GDP) in Honduras?
Provide a short and direct response. -7.52. In the year 2011, what is the difference between the Value added (% of GDP) of Gabon and Value added (% of GDP) of Honduras?
Make the answer very short. -26.96. In the year 2012, what is the difference between the Value added (% of GDP) in High income: nonOECD and Value added (% of GDP) in Least developed countries?
Your response must be concise. 9.33. In the year 2012, what is the difference between the Value added (% of GDP) in High income: nonOECD and Value added (% of GDP) in Gabon?
Your answer should be compact. 26.46. In the year 2012, what is the difference between the Value added (% of GDP) of High income: nonOECD and Value added (% of GDP) of Honduras?
Give a very brief answer. 1.42. In the year 2012, what is the difference between the Value added (% of GDP) of Least developed countries and Value added (% of GDP) of Gabon?
Provide a short and direct response. 17.13. In the year 2012, what is the difference between the Value added (% of GDP) of Least developed countries and Value added (% of GDP) of Honduras?
Make the answer very short. -7.91. In the year 2012, what is the difference between the Value added (% of GDP) in Gabon and Value added (% of GDP) in Honduras?
Make the answer very short. -25.04. In the year 2013, what is the difference between the Value added (% of GDP) in High income: nonOECD and Value added (% of GDP) in Least developed countries?
Your answer should be very brief. 8.86. In the year 2013, what is the difference between the Value added (% of GDP) of High income: nonOECD and Value added (% of GDP) of Gabon?
Make the answer very short. 24.36. In the year 2013, what is the difference between the Value added (% of GDP) of High income: nonOECD and Value added (% of GDP) of Honduras?
Make the answer very short. -0.48. In the year 2013, what is the difference between the Value added (% of GDP) in Least developed countries and Value added (% of GDP) in Gabon?
Provide a succinct answer. 15.5. In the year 2013, what is the difference between the Value added (% of GDP) of Least developed countries and Value added (% of GDP) of Honduras?
Make the answer very short. -9.34. In the year 2013, what is the difference between the Value added (% of GDP) of Gabon and Value added (% of GDP) of Honduras?
Provide a short and direct response. -24.84. What is the ratio of the Value added (% of GDP) in High income: nonOECD in 2006 to that in 2007?
Offer a very short reply. 0.98. What is the ratio of the Value added (% of GDP) in Least developed countries in 2006 to that in 2007?
Offer a terse response. 0.98. What is the ratio of the Value added (% of GDP) in Gabon in 2006 to that in 2007?
Your response must be concise. 0.97. What is the ratio of the Value added (% of GDP) of Honduras in 2006 to that in 2007?
Keep it short and to the point. 0.99. What is the ratio of the Value added (% of GDP) of High income: nonOECD in 2006 to that in 2008?
Your answer should be very brief. 0.97. What is the ratio of the Value added (% of GDP) of Gabon in 2006 to that in 2008?
Your answer should be compact. 1.06. What is the ratio of the Value added (% of GDP) of Honduras in 2006 to that in 2008?
Provide a succinct answer. 0.98. What is the ratio of the Value added (% of GDP) in High income: nonOECD in 2006 to that in 2009?
Offer a very short reply. 0.92. What is the ratio of the Value added (% of GDP) of Least developed countries in 2006 to that in 2009?
Make the answer very short. 0.97. What is the ratio of the Value added (% of GDP) of Gabon in 2006 to that in 2009?
Provide a short and direct response. 0.83. What is the ratio of the Value added (% of GDP) in Honduras in 2006 to that in 2009?
Your answer should be very brief. 0.96. What is the ratio of the Value added (% of GDP) of High income: nonOECD in 2006 to that in 2010?
Offer a terse response. 0.96. What is the ratio of the Value added (% of GDP) of Least developed countries in 2006 to that in 2010?
Give a very brief answer. 0.97. What is the ratio of the Value added (% of GDP) in Gabon in 2006 to that in 2010?
Provide a short and direct response. 0.88. What is the ratio of the Value added (% of GDP) of Honduras in 2006 to that in 2010?
Give a very brief answer. 0.96. What is the ratio of the Value added (% of GDP) in Least developed countries in 2006 to that in 2011?
Provide a succinct answer. 0.98. What is the ratio of the Value added (% of GDP) of Gabon in 2006 to that in 2011?
Your answer should be compact. 1.04. What is the ratio of the Value added (% of GDP) in Honduras in 2006 to that in 2011?
Make the answer very short. 1.01. What is the ratio of the Value added (% of GDP) in High income: nonOECD in 2006 to that in 2012?
Provide a short and direct response. 0.96. What is the ratio of the Value added (% of GDP) in Least developed countries in 2006 to that in 2012?
Ensure brevity in your answer.  0.98. What is the ratio of the Value added (% of GDP) in Gabon in 2006 to that in 2012?
Make the answer very short. 0.97. What is the ratio of the Value added (% of GDP) in High income: nonOECD in 2006 to that in 2013?
Give a very brief answer. 0.95. What is the ratio of the Value added (% of GDP) of Least developed countries in 2006 to that in 2013?
Make the answer very short. 0.96. What is the ratio of the Value added (% of GDP) in Gabon in 2006 to that in 2013?
Make the answer very short. 0.9. What is the ratio of the Value added (% of GDP) of Honduras in 2006 to that in 2013?
Give a very brief answer. 0.97. What is the ratio of the Value added (% of GDP) of High income: nonOECD in 2007 to that in 2008?
Ensure brevity in your answer.  0.98. What is the ratio of the Value added (% of GDP) in Least developed countries in 2007 to that in 2008?
Provide a succinct answer. 1.01. What is the ratio of the Value added (% of GDP) in Gabon in 2007 to that in 2008?
Keep it short and to the point. 1.09. What is the ratio of the Value added (% of GDP) in Honduras in 2007 to that in 2008?
Your answer should be very brief. 0.99. What is the ratio of the Value added (% of GDP) in High income: nonOECD in 2007 to that in 2009?
Your response must be concise. 0.93. What is the ratio of the Value added (% of GDP) in Least developed countries in 2007 to that in 2009?
Provide a short and direct response. 0.99. What is the ratio of the Value added (% of GDP) in Gabon in 2007 to that in 2009?
Keep it short and to the point. 0.85. What is the ratio of the Value added (% of GDP) in Honduras in 2007 to that in 2009?
Keep it short and to the point. 0.97. What is the ratio of the Value added (% of GDP) in High income: nonOECD in 2007 to that in 2010?
Keep it short and to the point. 0.97. What is the ratio of the Value added (% of GDP) of Least developed countries in 2007 to that in 2010?
Make the answer very short. 0.99. What is the ratio of the Value added (% of GDP) in Gabon in 2007 to that in 2010?
Your answer should be compact. 0.91. What is the ratio of the Value added (% of GDP) of Honduras in 2007 to that in 2010?
Your response must be concise. 0.97. What is the ratio of the Value added (% of GDP) in High income: nonOECD in 2007 to that in 2011?
Offer a terse response. 0.98. What is the ratio of the Value added (% of GDP) in Least developed countries in 2007 to that in 2011?
Keep it short and to the point. 1. What is the ratio of the Value added (% of GDP) of Gabon in 2007 to that in 2011?
Ensure brevity in your answer.  1.07. What is the ratio of the Value added (% of GDP) of Honduras in 2007 to that in 2011?
Your answer should be very brief. 1.03. What is the ratio of the Value added (% of GDP) in High income: nonOECD in 2007 to that in 2012?
Offer a very short reply. 0.97. What is the ratio of the Value added (% of GDP) of Least developed countries in 2007 to that in 2012?
Give a very brief answer. 1. What is the ratio of the Value added (% of GDP) in Gabon in 2007 to that in 2012?
Offer a very short reply. 1. What is the ratio of the Value added (% of GDP) in Honduras in 2007 to that in 2012?
Provide a succinct answer. 1.02. What is the ratio of the Value added (% of GDP) of High income: nonOECD in 2007 to that in 2013?
Provide a short and direct response. 0.97. What is the ratio of the Value added (% of GDP) in Least developed countries in 2007 to that in 2013?
Your answer should be compact. 0.98. What is the ratio of the Value added (% of GDP) in Gabon in 2007 to that in 2013?
Provide a succinct answer. 0.93. What is the ratio of the Value added (% of GDP) of Honduras in 2007 to that in 2013?
Keep it short and to the point. 0.98. What is the ratio of the Value added (% of GDP) of High income: nonOECD in 2008 to that in 2009?
Provide a short and direct response. 0.95. What is the ratio of the Value added (% of GDP) in Least developed countries in 2008 to that in 2009?
Ensure brevity in your answer.  0.97. What is the ratio of the Value added (% of GDP) of Gabon in 2008 to that in 2009?
Provide a succinct answer. 0.78. What is the ratio of the Value added (% of GDP) of Honduras in 2008 to that in 2009?
Provide a succinct answer. 0.98. What is the ratio of the Value added (% of GDP) of Least developed countries in 2008 to that in 2010?
Your answer should be compact. 0.98. What is the ratio of the Value added (% of GDP) of Gabon in 2008 to that in 2010?
Give a very brief answer. 0.83. What is the ratio of the Value added (% of GDP) in Honduras in 2008 to that in 2010?
Your response must be concise. 0.98. What is the ratio of the Value added (% of GDP) of Least developed countries in 2008 to that in 2011?
Provide a short and direct response. 0.98. What is the ratio of the Value added (% of GDP) in Honduras in 2008 to that in 2011?
Your response must be concise. 1.03. What is the ratio of the Value added (% of GDP) in High income: nonOECD in 2008 to that in 2012?
Keep it short and to the point. 0.99. What is the ratio of the Value added (% of GDP) in Least developed countries in 2008 to that in 2012?
Give a very brief answer. 0.99. What is the ratio of the Value added (% of GDP) in Gabon in 2008 to that in 2012?
Your answer should be very brief. 0.91. What is the ratio of the Value added (% of GDP) of Honduras in 2008 to that in 2012?
Your response must be concise. 1.03. What is the ratio of the Value added (% of GDP) of High income: nonOECD in 2008 to that in 2013?
Offer a terse response. 0.98. What is the ratio of the Value added (% of GDP) of Least developed countries in 2008 to that in 2013?
Provide a succinct answer. 0.97. What is the ratio of the Value added (% of GDP) of Gabon in 2008 to that in 2013?
Your response must be concise. 0.85. What is the ratio of the Value added (% of GDP) of High income: nonOECD in 2009 to that in 2010?
Offer a terse response. 1.04. What is the ratio of the Value added (% of GDP) in Gabon in 2009 to that in 2010?
Keep it short and to the point. 1.06. What is the ratio of the Value added (% of GDP) of Honduras in 2009 to that in 2010?
Your answer should be compact. 1.01. What is the ratio of the Value added (% of GDP) of High income: nonOECD in 2009 to that in 2011?
Keep it short and to the point. 1.05. What is the ratio of the Value added (% of GDP) in Gabon in 2009 to that in 2011?
Provide a succinct answer. 1.26. What is the ratio of the Value added (% of GDP) of Honduras in 2009 to that in 2011?
Keep it short and to the point. 1.06. What is the ratio of the Value added (% of GDP) in High income: nonOECD in 2009 to that in 2012?
Give a very brief answer. 1.04. What is the ratio of the Value added (% of GDP) of Least developed countries in 2009 to that in 2012?
Give a very brief answer. 1.01. What is the ratio of the Value added (% of GDP) in Gabon in 2009 to that in 2012?
Offer a terse response. 1.17. What is the ratio of the Value added (% of GDP) in Honduras in 2009 to that in 2012?
Give a very brief answer. 1.05. What is the ratio of the Value added (% of GDP) in High income: nonOECD in 2009 to that in 2013?
Offer a terse response. 1.03. What is the ratio of the Value added (% of GDP) of Least developed countries in 2009 to that in 2013?
Offer a terse response. 0.99. What is the ratio of the Value added (% of GDP) of Gabon in 2009 to that in 2013?
Your answer should be very brief. 1.09. What is the ratio of the Value added (% of GDP) of Honduras in 2009 to that in 2013?
Ensure brevity in your answer.  1.01. What is the ratio of the Value added (% of GDP) in High income: nonOECD in 2010 to that in 2011?
Give a very brief answer. 1.01. What is the ratio of the Value added (% of GDP) in Least developed countries in 2010 to that in 2011?
Your answer should be compact. 1.01. What is the ratio of the Value added (% of GDP) in Gabon in 2010 to that in 2011?
Offer a very short reply. 1.18. What is the ratio of the Value added (% of GDP) of Honduras in 2010 to that in 2011?
Offer a terse response. 1.05. What is the ratio of the Value added (% of GDP) in High income: nonOECD in 2010 to that in 2012?
Keep it short and to the point. 1. What is the ratio of the Value added (% of GDP) of Gabon in 2010 to that in 2012?
Provide a succinct answer. 1.1. What is the ratio of the Value added (% of GDP) in Honduras in 2010 to that in 2012?
Ensure brevity in your answer.  1.05. What is the ratio of the Value added (% of GDP) in Least developed countries in 2010 to that in 2013?
Your answer should be very brief. 0.99. What is the ratio of the Value added (% of GDP) of Gabon in 2010 to that in 2013?
Offer a very short reply. 1.02. What is the ratio of the Value added (% of GDP) in Honduras in 2010 to that in 2013?
Your response must be concise. 1.01. What is the ratio of the Value added (% of GDP) in High income: nonOECD in 2011 to that in 2012?
Make the answer very short. 0.99. What is the ratio of the Value added (% of GDP) of Least developed countries in 2011 to that in 2012?
Provide a succinct answer. 1. What is the ratio of the Value added (% of GDP) in Gabon in 2011 to that in 2012?
Ensure brevity in your answer.  0.93. What is the ratio of the Value added (% of GDP) of High income: nonOECD in 2011 to that in 2013?
Ensure brevity in your answer.  0.98. What is the ratio of the Value added (% of GDP) in Least developed countries in 2011 to that in 2013?
Ensure brevity in your answer.  0.98. What is the ratio of the Value added (% of GDP) of Gabon in 2011 to that in 2013?
Provide a short and direct response. 0.86. What is the ratio of the Value added (% of GDP) of Honduras in 2011 to that in 2013?
Your response must be concise. 0.96. What is the ratio of the Value added (% of GDP) in High income: nonOECD in 2012 to that in 2013?
Make the answer very short. 0.99. What is the ratio of the Value added (% of GDP) in Least developed countries in 2012 to that in 2013?
Offer a very short reply. 0.98. What is the ratio of the Value added (% of GDP) of Gabon in 2012 to that in 2013?
Your answer should be very brief. 0.93. What is the ratio of the Value added (% of GDP) of Honduras in 2012 to that in 2013?
Your answer should be very brief. 0.96. What is the difference between the highest and the second highest Value added (% of GDP) of High income: nonOECD?
Keep it short and to the point. 2.02. What is the difference between the highest and the second highest Value added (% of GDP) in Least developed countries?
Offer a terse response. 0.3. What is the difference between the highest and the second highest Value added (% of GDP) in Gabon?
Provide a short and direct response. 2.27. What is the difference between the highest and the second highest Value added (% of GDP) in Honduras?
Offer a terse response. 0.34. What is the difference between the highest and the lowest Value added (% of GDP) in High income: nonOECD?
Your answer should be compact. 4.97. What is the difference between the highest and the lowest Value added (% of GDP) in Least developed countries?
Keep it short and to the point. 1.88. What is the difference between the highest and the lowest Value added (% of GDP) of Gabon?
Give a very brief answer. 8.29. What is the difference between the highest and the lowest Value added (% of GDP) of Honduras?
Give a very brief answer. 3.34. 